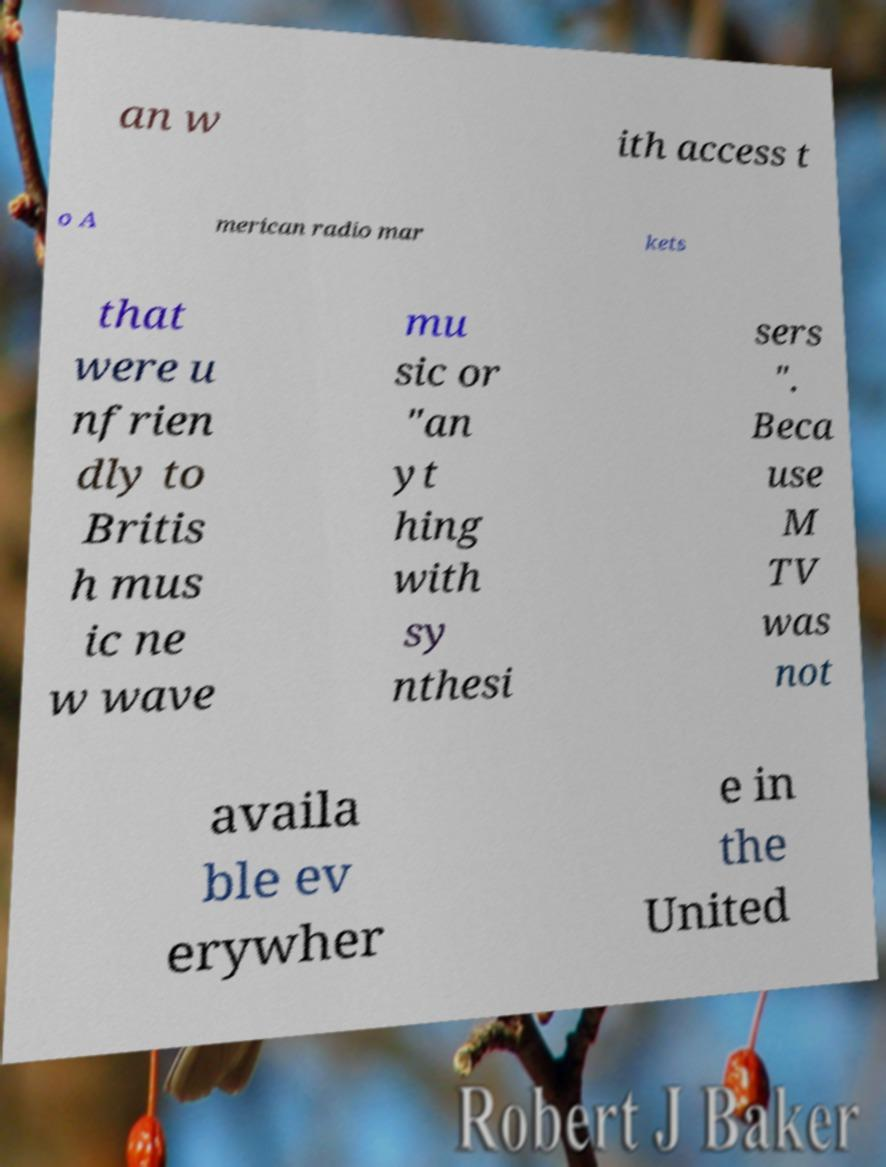Can you read and provide the text displayed in the image?This photo seems to have some interesting text. Can you extract and type it out for me? an w ith access t o A merican radio mar kets that were u nfrien dly to Britis h mus ic ne w wave mu sic or "an yt hing with sy nthesi sers ". Beca use M TV was not availa ble ev erywher e in the United 